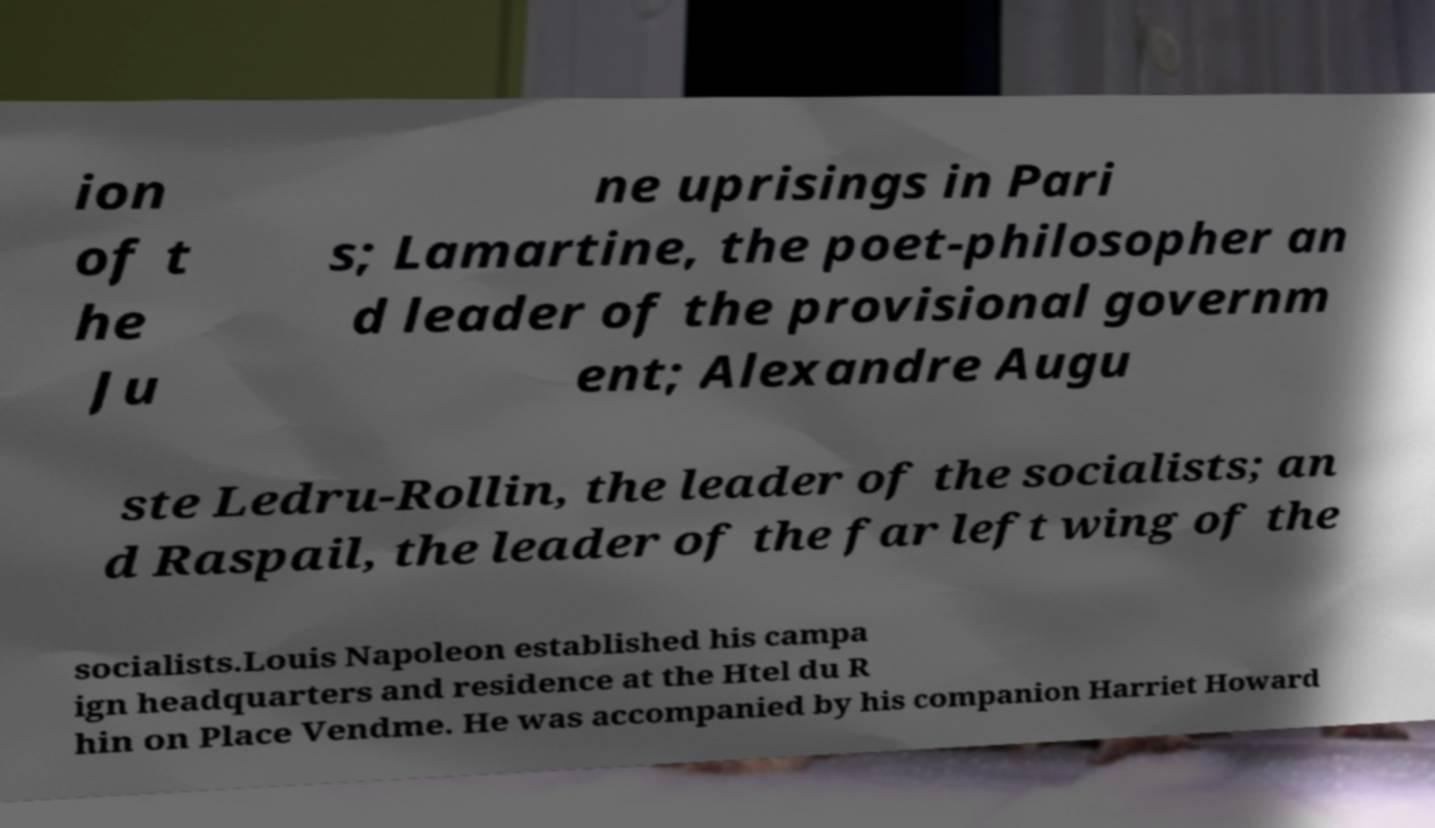I need the written content from this picture converted into text. Can you do that? ion of t he Ju ne uprisings in Pari s; Lamartine, the poet-philosopher an d leader of the provisional governm ent; Alexandre Augu ste Ledru-Rollin, the leader of the socialists; an d Raspail, the leader of the far left wing of the socialists.Louis Napoleon established his campa ign headquarters and residence at the Htel du R hin on Place Vendme. He was accompanied by his companion Harriet Howard 